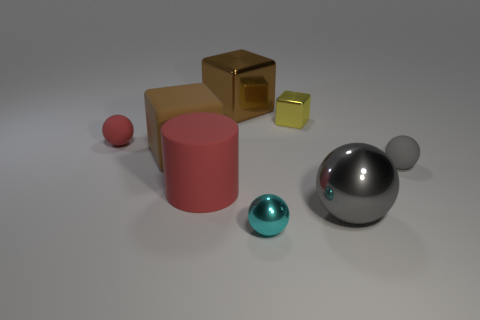What number of big rubber cylinders are on the right side of the matte ball that is on the left side of the large thing that is to the right of the yellow metal block?
Provide a short and direct response. 1. Does the brown thing that is left of the big red object have the same shape as the red thing that is on the right side of the tiny red thing?
Keep it short and to the point. No. What number of things are tiny metal spheres or cubes?
Give a very brief answer. 4. The small object to the left of the tiny object in front of the large red matte cylinder is made of what material?
Offer a very short reply. Rubber. Is there a matte thing of the same color as the large ball?
Offer a terse response. Yes. The other block that is the same size as the rubber block is what color?
Ensure brevity in your answer.  Brown. There is a big object that is behind the rubber ball that is on the left side of the tiny shiny sphere that is on the right side of the large red object; what is its material?
Make the answer very short. Metal. Does the big metallic cube have the same color as the rubber object to the right of the big gray sphere?
Provide a succinct answer. No. How many objects are either big red cylinders in front of the tiny red thing or small metallic things in front of the small yellow cube?
Provide a succinct answer. 2. There is a gray thing that is in front of the gray ball that is to the right of the gray metallic object; what shape is it?
Your answer should be very brief. Sphere. 